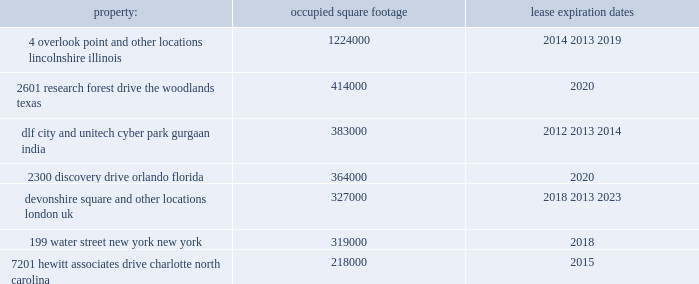Available , we do not expect any transactions to have a significant impact on our reported income tax expense .
In connection with the completion of the reorganization , we will reevaluate the ability to realize our deferred tax assets related to u.s .
Operations under the new aon uk corporate structure and we may recognize a non-cash , deferred tax expense upon the conclusion of this evaluation .
Based on information currently available , we do not expect the additional deferred tax expense , if any , to be significant .
The reorganization will result in additional ongoing costs to us .
The completion of the reorganization will result in an increase in some of our ongoing expenses and require us to incur some new expenses .
Some costs , including those related to employees in our u.k .
Offices and holding board meetings in the u.k. , are expected to be higher than would be the case if our principal executive offices were not relocated to the u.k. .
We also expect to incur new expenses , including professional fees and sdrt in connection with settlement of equity-based awards under our stock or share incentive plans , to comply with u.k .
Corporate and tax laws .
Item 1b .
Unresolved staff comments .
Item 2 .
Properties .
We have offices in various locations throughout the world .
Substantially all of our offices are located in leased premises .
We maintain our corporate headquarters at 200 e .
Randolph street in chicago , illinois , where we occupy approximately 355000 square feet of space under an operating lease agreement that expires in 2013 .
There are two five-year renewal options at current market rates .
We own one building at pallbergweg 2-4 , amsterdam , the netherlands ( 150000 square feet ) .
The following are additional significant leased properties , along with the occupied square footage and expiration. .
7201 hewitt associates drive , charlotte , north carolina .
218000 2015 the locations in lincolnshire , illinois , the woodlands , texas , orlando , florida , and charlotte north carolina , each of which were acquired as part of the hewitt acquisition in 2010 , are primarily dedicated to our hr solutions segment .
The other locations listed above house personnel from each of our business segments .
In november 2011 , aon entered into an agreement to lease 190000 square feet in a new building to be constructed in london , united kingdom .
The agreement is contingent upon the completion of the building construction .
Aon expects to move into the new building in 2015 when it exercises an early break option at the devonshire square location. .
Considering the properties with lease expiration dates in 2020 , what is the average occupied square footage? 
Rationale: it is the sum of the occupied square footage for both years divided by two to represent the average .
Computations: ((414000 + 364000) / 2)
Answer: 389000.0. 